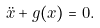Convert formula to latex. <formula><loc_0><loc_0><loc_500><loc_500>\ddot { x } + g ( x ) = 0 .</formula> 